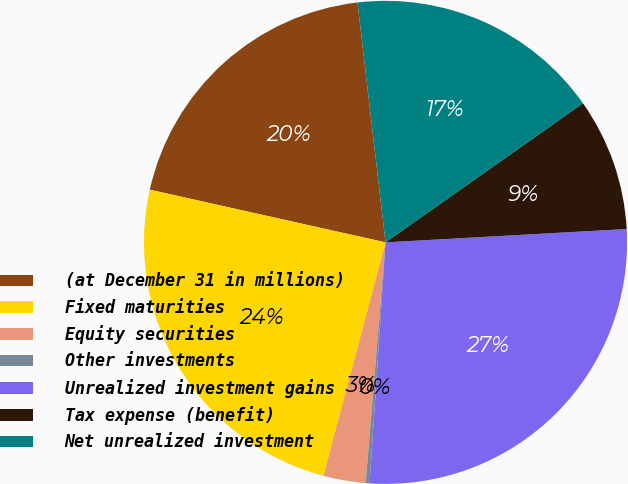Convert chart. <chart><loc_0><loc_0><loc_500><loc_500><pie_chart><fcel>(at December 31 in millions)<fcel>Fixed maturities<fcel>Equity securities<fcel>Other investments<fcel>Unrealized investment gains<fcel>Tax expense (benefit)<fcel>Net unrealized investment<nl><fcel>19.65%<fcel>24.36%<fcel>2.83%<fcel>0.26%<fcel>26.93%<fcel>8.89%<fcel>17.08%<nl></chart> 